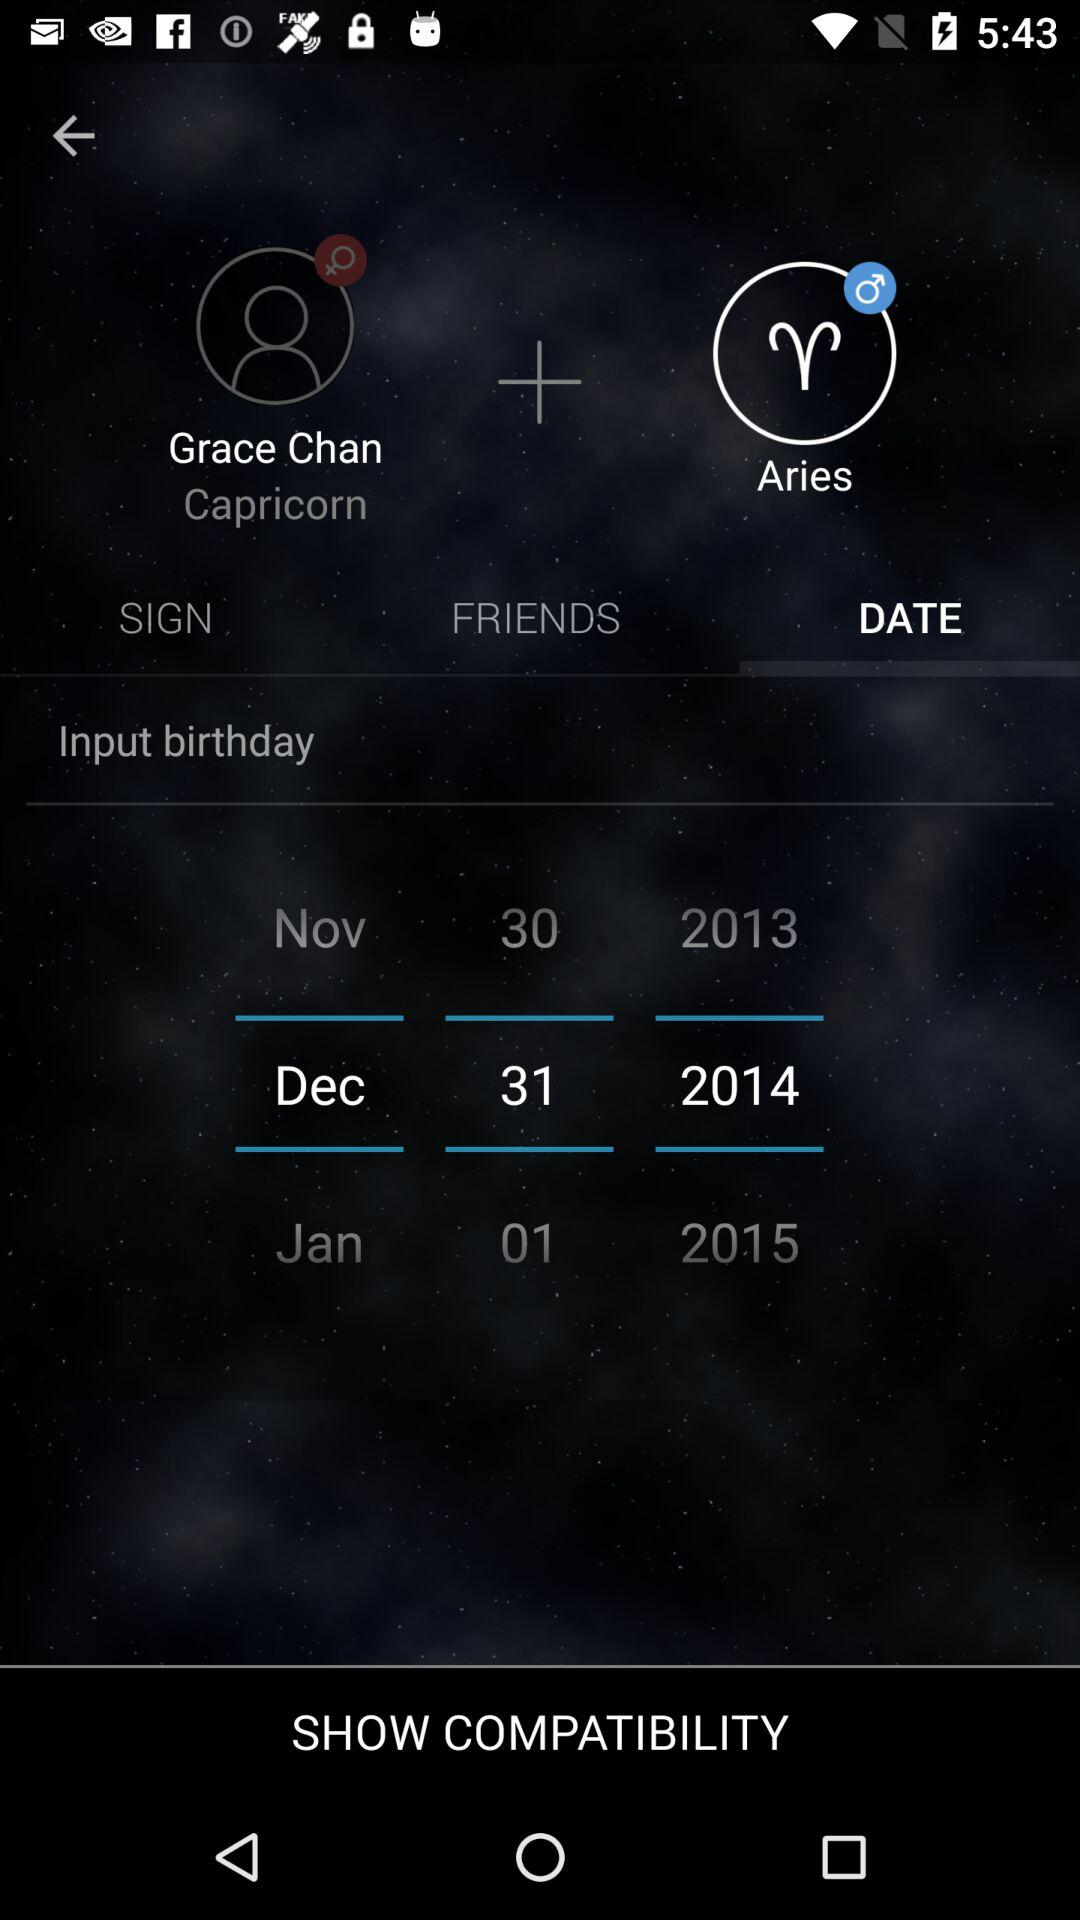What is the zodiac sign of Grace Chan? The zodiac sign is "Capricorn". 